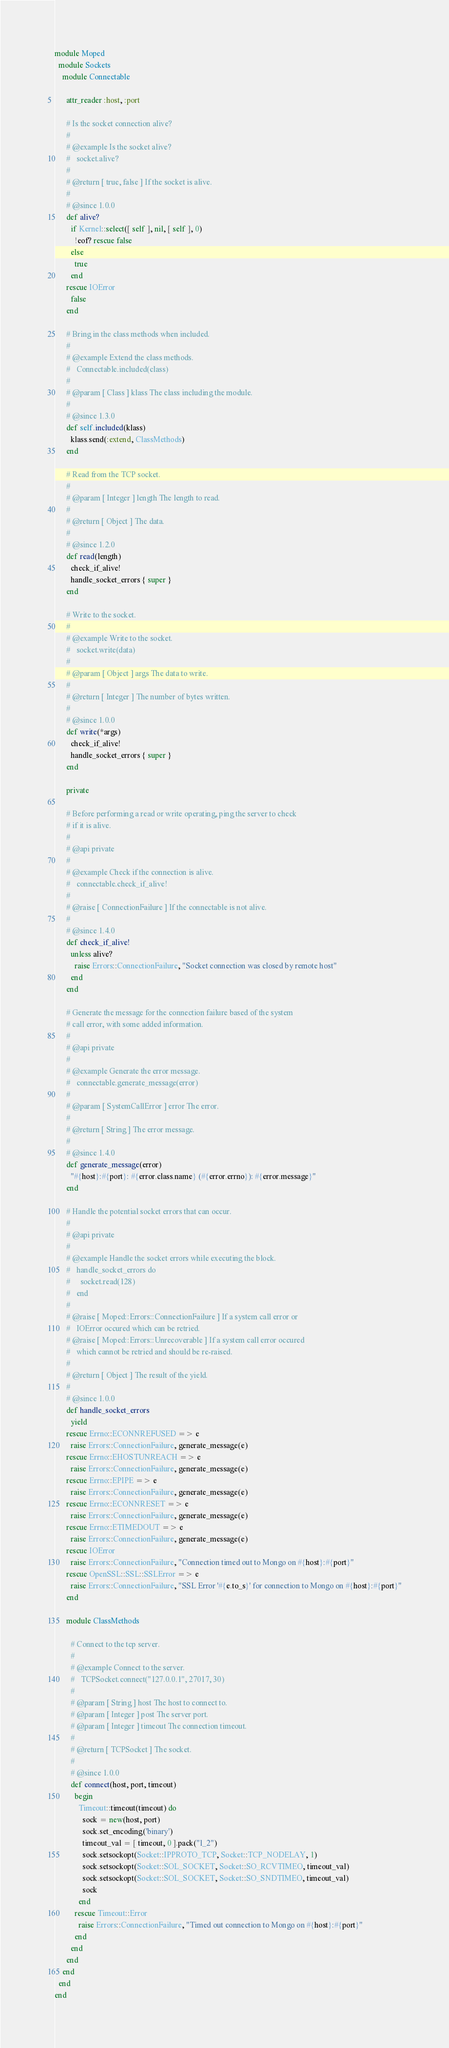Convert code to text. <code><loc_0><loc_0><loc_500><loc_500><_Ruby_>module Moped
  module Sockets
    module Connectable

      attr_reader :host, :port

      # Is the socket connection alive?
      #
      # @example Is the socket alive?
      #   socket.alive?
      #
      # @return [ true, false ] If the socket is alive.
      #
      # @since 1.0.0
      def alive?
        if Kernel::select([ self ], nil, [ self ], 0)
          !eof? rescue false
        else
          true
        end
      rescue IOError
        false
      end

      # Bring in the class methods when included.
      #
      # @example Extend the class methods.
      #   Connectable.included(class)
      #
      # @param [ Class ] klass The class including the module.
      #
      # @since 1.3.0
      def self.included(klass)
        klass.send(:extend, ClassMethods)
      end

      # Read from the TCP socket.
      #
      # @param [ Integer ] length The length to read.
      #
      # @return [ Object ] The data.
      #
      # @since 1.2.0
      def read(length)
        check_if_alive!
        handle_socket_errors { super }
      end

      # Write to the socket.
      #
      # @example Write to the socket.
      #   socket.write(data)
      #
      # @param [ Object ] args The data to write.
      #
      # @return [ Integer ] The number of bytes written.
      #
      # @since 1.0.0
      def write(*args)
        check_if_alive!
        handle_socket_errors { super }
      end

      private

      # Before performing a read or write operating, ping the server to check
      # if it is alive.
      #
      # @api private
      #
      # @example Check if the connection is alive.
      #   connectable.check_if_alive!
      #
      # @raise [ ConnectionFailure ] If the connectable is not alive.
      #
      # @since 1.4.0
      def check_if_alive!
        unless alive?
          raise Errors::ConnectionFailure, "Socket connection was closed by remote host"
        end
      end

      # Generate the message for the connection failure based of the system
      # call error, with some added information.
      #
      # @api private
      #
      # @example Generate the error message.
      #   connectable.generate_message(error)
      #
      # @param [ SystemCallError ] error The error.
      #
      # @return [ String ] The error message.
      #
      # @since 1.4.0
      def generate_message(error)
        "#{host}:#{port}: #{error.class.name} (#{error.errno}): #{error.message}"
      end

      # Handle the potential socket errors that can occur.
      #
      # @api private
      #
      # @example Handle the socket errors while executing the block.
      #   handle_socket_errors do
      #     socket.read(128)
      #   end
      #
      # @raise [ Moped::Errors::ConnectionFailure ] If a system call error or
      #   IOError occured which can be retried.
      # @raise [ Moped::Errors::Unrecoverable ] If a system call error occured
      #   which cannot be retried and should be re-raised.
      #
      # @return [ Object ] The result of the yield.
      #
      # @since 1.0.0
      def handle_socket_errors
        yield
      rescue Errno::ECONNREFUSED => e
        raise Errors::ConnectionFailure, generate_message(e)
      rescue Errno::EHOSTUNREACH => e
        raise Errors::ConnectionFailure, generate_message(e)
      rescue Errno::EPIPE => e
        raise Errors::ConnectionFailure, generate_message(e)
      rescue Errno::ECONNRESET => e
        raise Errors::ConnectionFailure, generate_message(e)
      rescue Errno::ETIMEDOUT => e
        raise Errors::ConnectionFailure, generate_message(e)
      rescue IOError
        raise Errors::ConnectionFailure, "Connection timed out to Mongo on #{host}:#{port}"
      rescue OpenSSL::SSL::SSLError => e
        raise Errors::ConnectionFailure, "SSL Error '#{e.to_s}' for connection to Mongo on #{host}:#{port}"
      end

      module ClassMethods

        # Connect to the tcp server.
        #
        # @example Connect to the server.
        #   TCPSocket.connect("127.0.0.1", 27017, 30)
        #
        # @param [ String ] host The host to connect to.
        # @param [ Integer ] post The server port.
        # @param [ Integer ] timeout The connection timeout.
        #
        # @return [ TCPSocket ] The socket.
        #
        # @since 1.0.0
        def connect(host, port, timeout)
          begin
            Timeout::timeout(timeout) do
              sock = new(host, port)
              sock.set_encoding('binary')
              timeout_val = [ timeout, 0 ].pack("l_2")
              sock.setsockopt(Socket::IPPROTO_TCP, Socket::TCP_NODELAY, 1)
              sock.setsockopt(Socket::SOL_SOCKET, Socket::SO_RCVTIMEO, timeout_val)
              sock.setsockopt(Socket::SOL_SOCKET, Socket::SO_SNDTIMEO, timeout_val)
              sock
            end
          rescue Timeout::Error
            raise Errors::ConnectionFailure, "Timed out connection to Mongo on #{host}:#{port}"
          end
        end
      end
    end
  end
end
</code> 